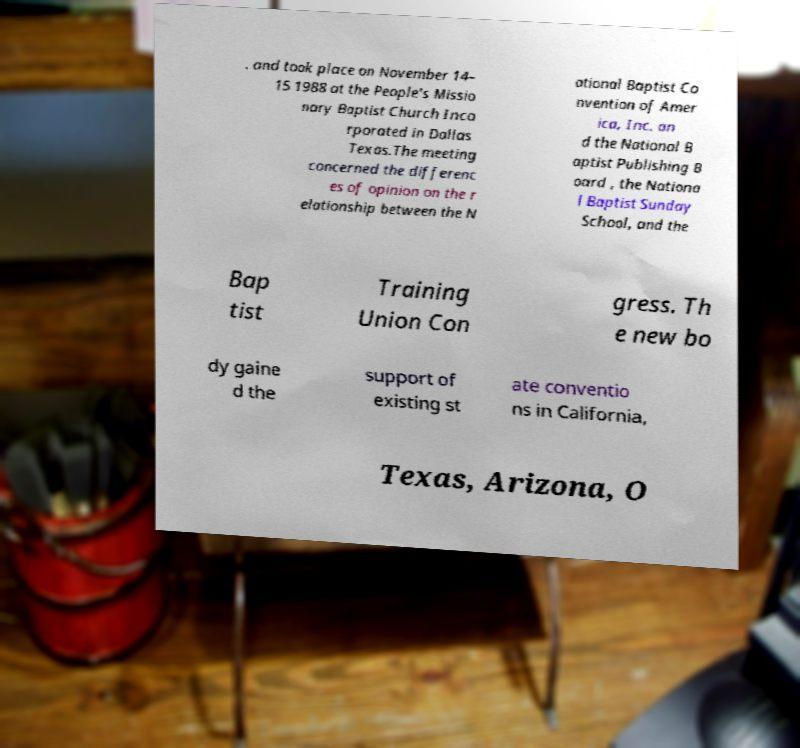I need the written content from this picture converted into text. Can you do that? . and took place on November 14– 15 1988 at the People's Missio nary Baptist Church Inco rporated in Dallas Texas.The meeting concerned the differenc es of opinion on the r elationship between the N ational Baptist Co nvention of Amer ica, Inc. an d the National B aptist Publishing B oard , the Nationa l Baptist Sunday School, and the Bap tist Training Union Con gress. Th e new bo dy gaine d the support of existing st ate conventio ns in California, Texas, Arizona, O 